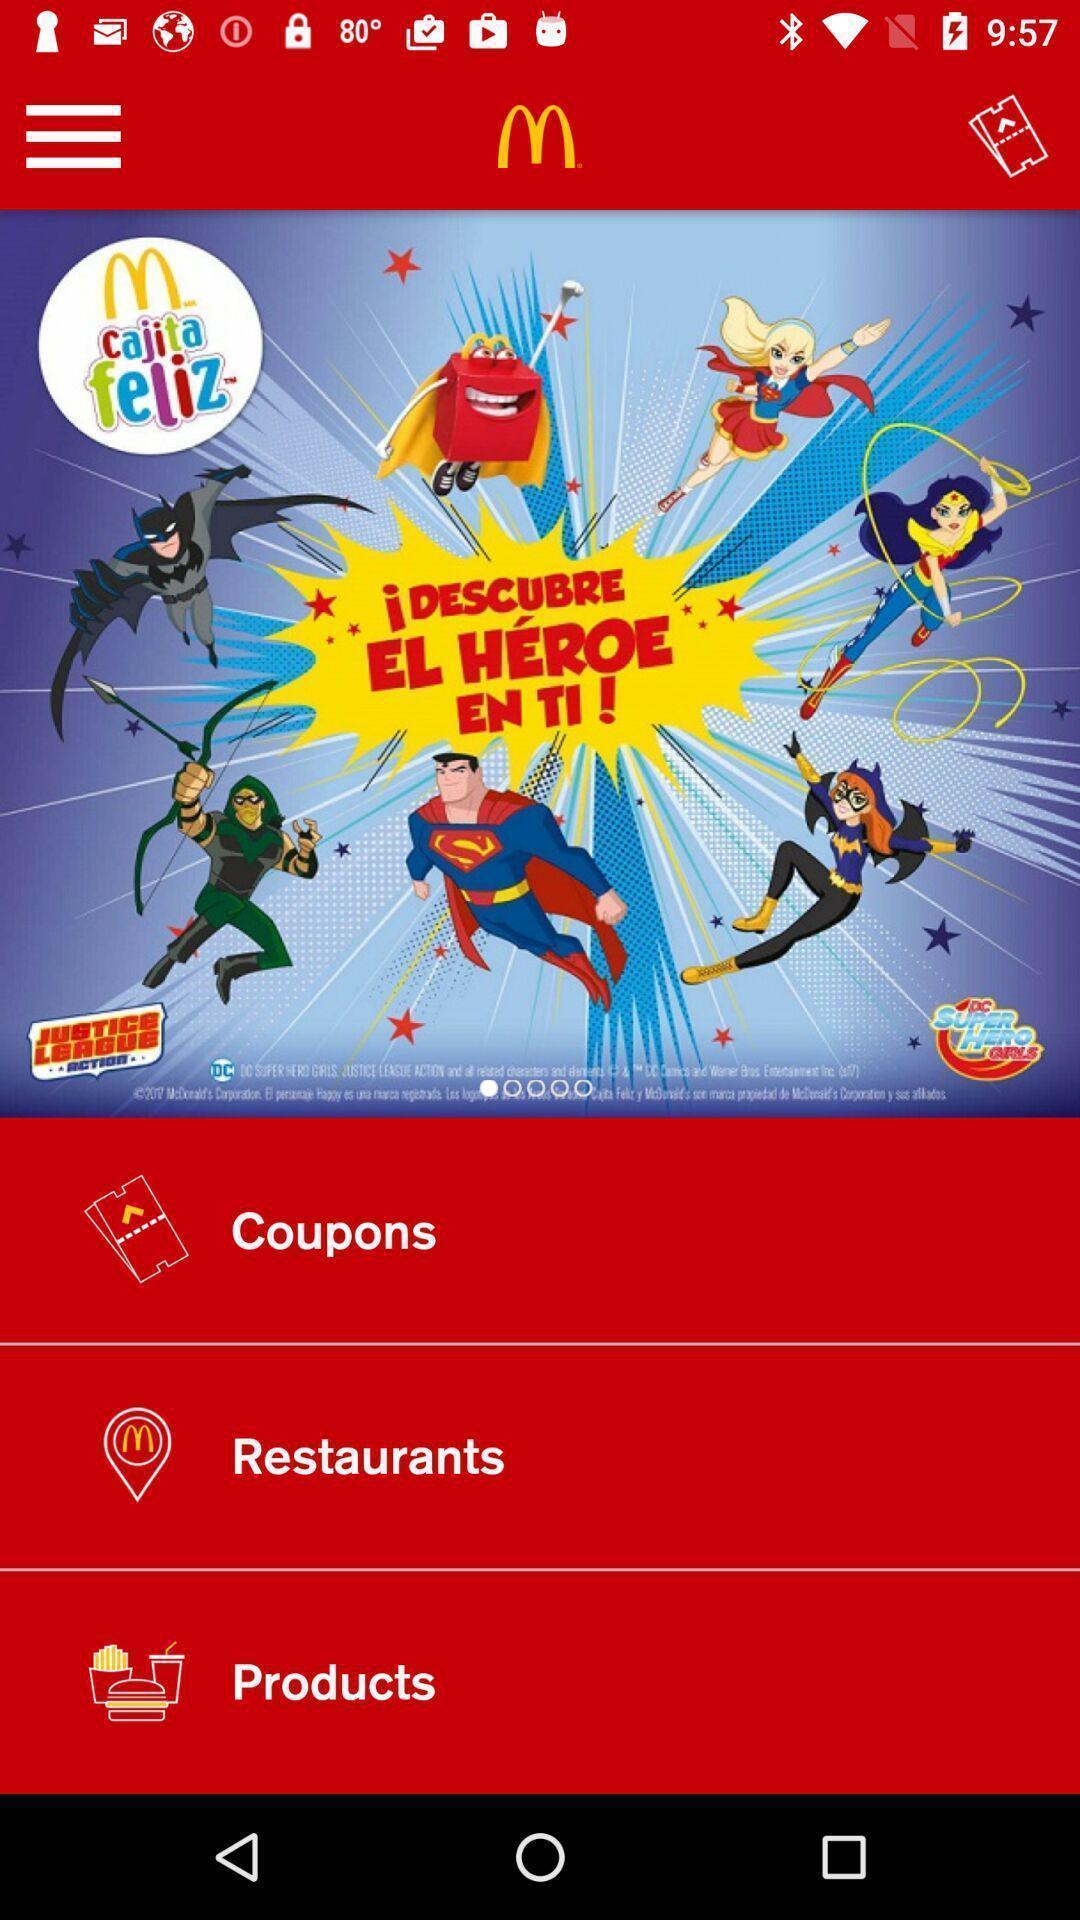Give me a narrative description of this picture. Screen shows about coupons on a food app. 